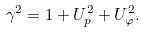Convert formula to latex. <formula><loc_0><loc_0><loc_500><loc_500>\gamma ^ { 2 } = 1 + U _ { p } ^ { 2 } + U _ { \varphi } ^ { 2 } .</formula> 